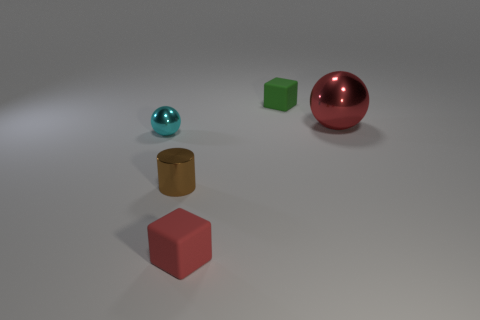Does the small red thing have the same shape as the green thing?
Provide a short and direct response. Yes. What size is the brown object?
Offer a very short reply. Small. Are there more cubes that are behind the tiny brown metallic object than red blocks that are behind the cyan sphere?
Ensure brevity in your answer.  Yes. Are there any matte cubes behind the red cube?
Offer a terse response. Yes. Is there a green block that has the same size as the cyan metal object?
Offer a terse response. Yes. The large object that is the same material as the cylinder is what color?
Your answer should be compact. Red. What is the material of the big object?
Offer a very short reply. Metal. What is the shape of the tiny green matte object?
Make the answer very short. Cube. How many tiny matte objects are the same color as the small sphere?
Make the answer very short. 0. What is the material of the big sphere that is behind the tiny rubber thing that is in front of the small brown thing in front of the green thing?
Offer a very short reply. Metal. 